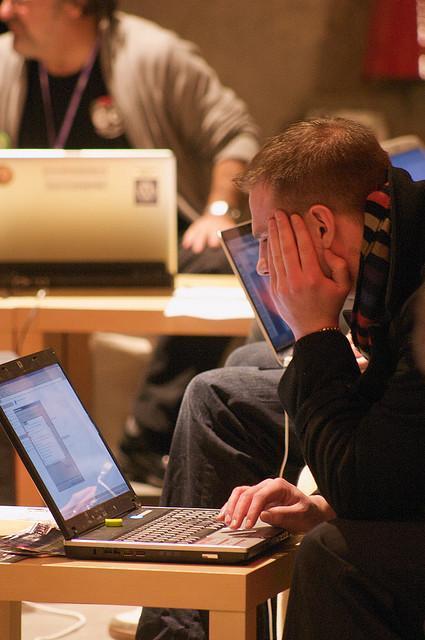How many laptops can be seen in this picture?
Give a very brief answer. 4. How many people are there?
Give a very brief answer. 3. How many laptops can be seen?
Give a very brief answer. 3. How many people is the elephant interacting with?
Give a very brief answer. 0. 